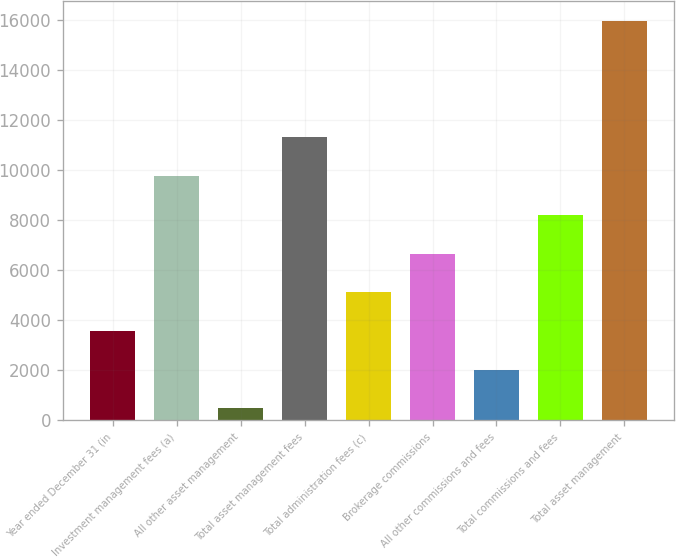<chart> <loc_0><loc_0><loc_500><loc_500><bar_chart><fcel>Year ended December 31 (in<fcel>Investment management fees (a)<fcel>All other asset management<fcel>Total asset management fees<fcel>Total administration fees (c)<fcel>Brokerage commissions<fcel>All other commissions and fees<fcel>Total commissions and fees<fcel>Total asset management<nl><fcel>3567.8<fcel>9749.4<fcel>477<fcel>11294.8<fcel>5113.2<fcel>6658.6<fcel>2022.4<fcel>8204<fcel>15931<nl></chart> 